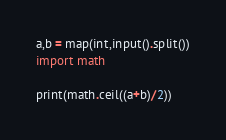<code> <loc_0><loc_0><loc_500><loc_500><_Python_>a,b = map(int,input().split())
import math

print(math.ceil((a+b)/2))</code> 